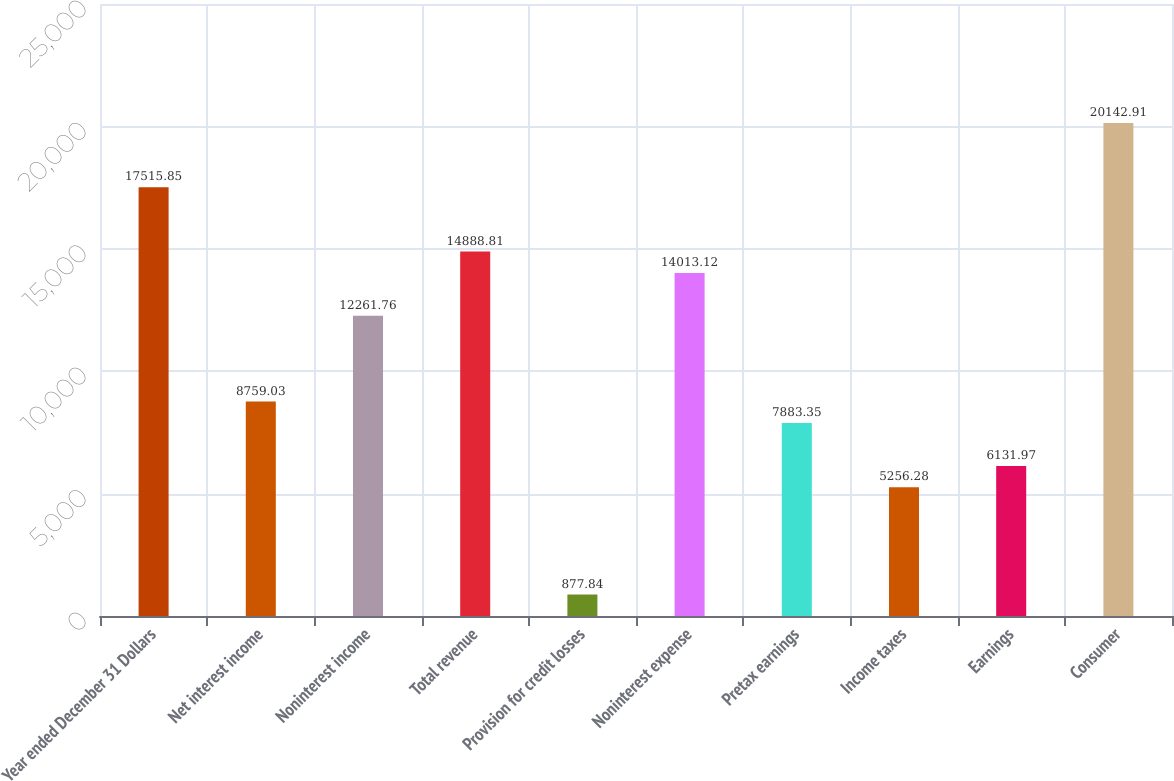Convert chart to OTSL. <chart><loc_0><loc_0><loc_500><loc_500><bar_chart><fcel>Year ended December 31 Dollars<fcel>Net interest income<fcel>Noninterest income<fcel>Total revenue<fcel>Provision for credit losses<fcel>Noninterest expense<fcel>Pretax earnings<fcel>Income taxes<fcel>Earnings<fcel>Consumer<nl><fcel>17515.8<fcel>8759.03<fcel>12261.8<fcel>14888.8<fcel>877.84<fcel>14013.1<fcel>7883.35<fcel>5256.28<fcel>6131.97<fcel>20142.9<nl></chart> 